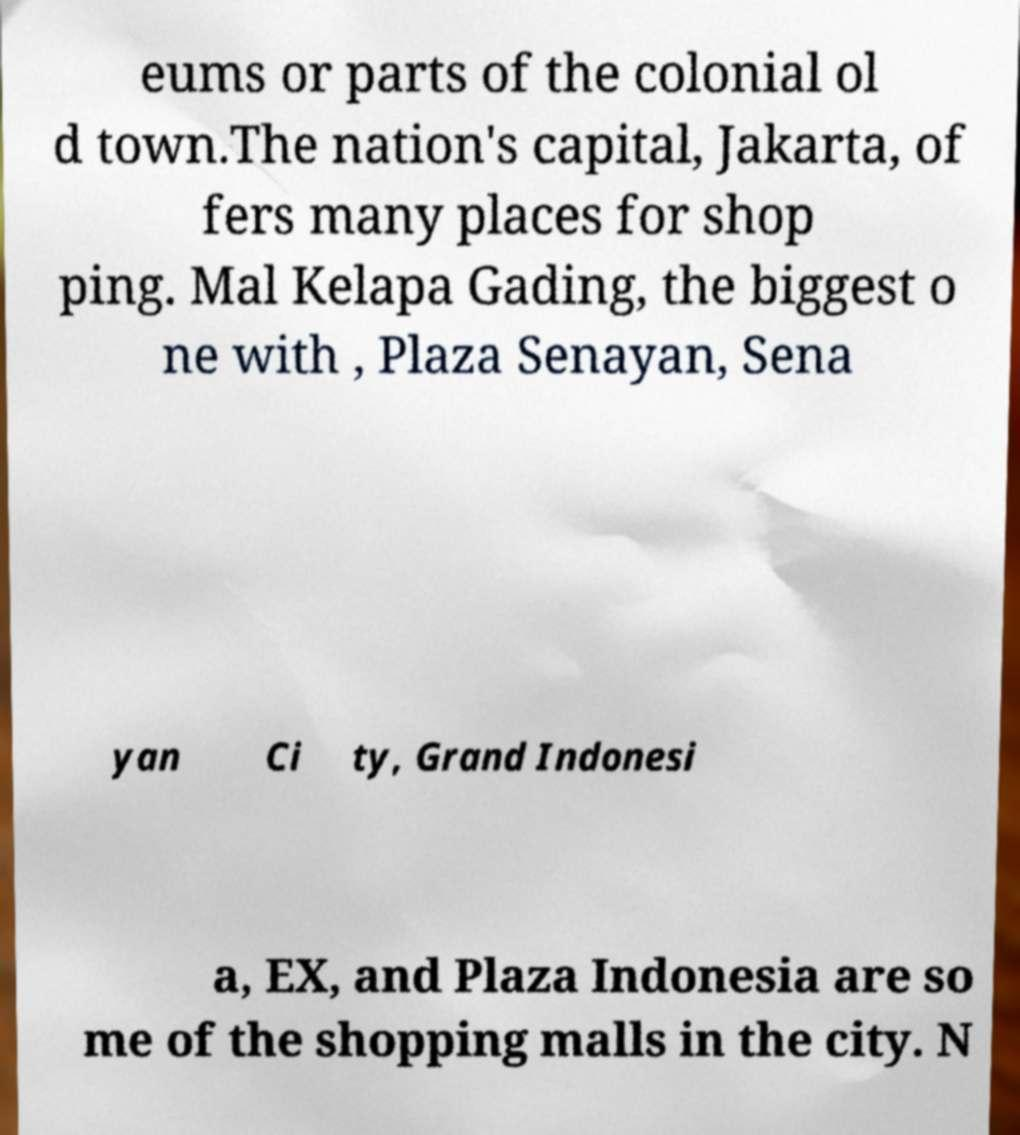Could you assist in decoding the text presented in this image and type it out clearly? eums or parts of the colonial ol d town.The nation's capital, Jakarta, of fers many places for shop ping. Mal Kelapa Gading, the biggest o ne with , Plaza Senayan, Sena yan Ci ty, Grand Indonesi a, EX, and Plaza Indonesia are so me of the shopping malls in the city. N 